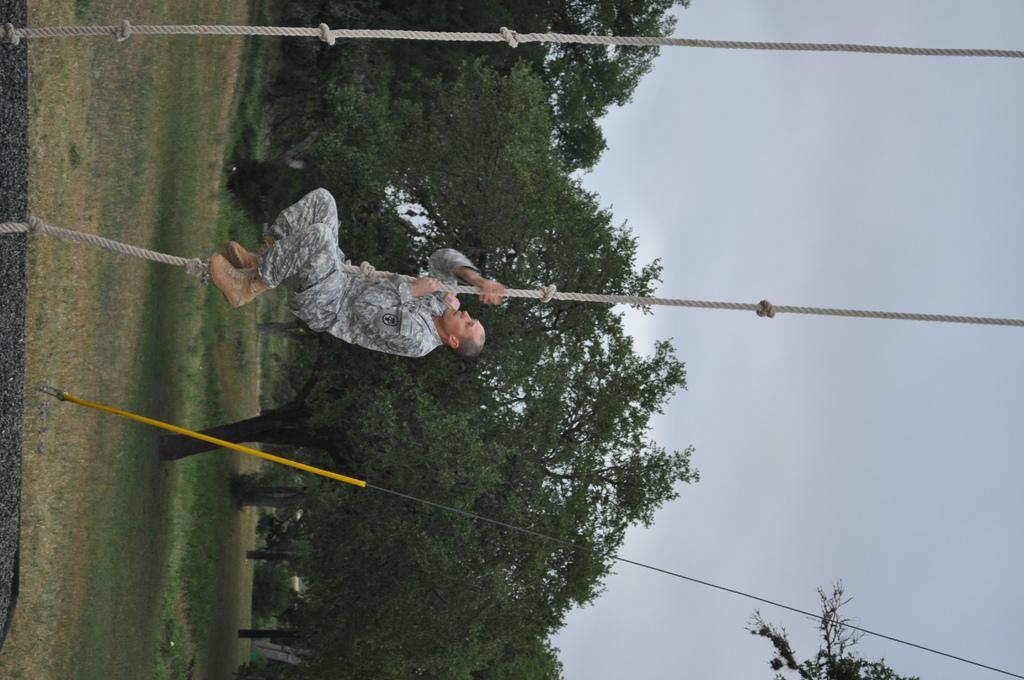Please provide a concise description of this image. In the picture I can see a man is climbing on the rope. The man is wearing a uniform. I can also see ropes, trees, the sky and some other objects. 